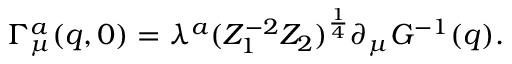Convert formula to latex. <formula><loc_0><loc_0><loc_500><loc_500>\Gamma _ { \mu } ^ { a } ( q , 0 ) = \lambda ^ { a } ( Z _ { 1 } ^ { - 2 } Z _ { 2 } ) ^ { \frac { 1 } { 4 } } \partial _ { \mu } G ^ { - 1 } ( q ) .</formula> 